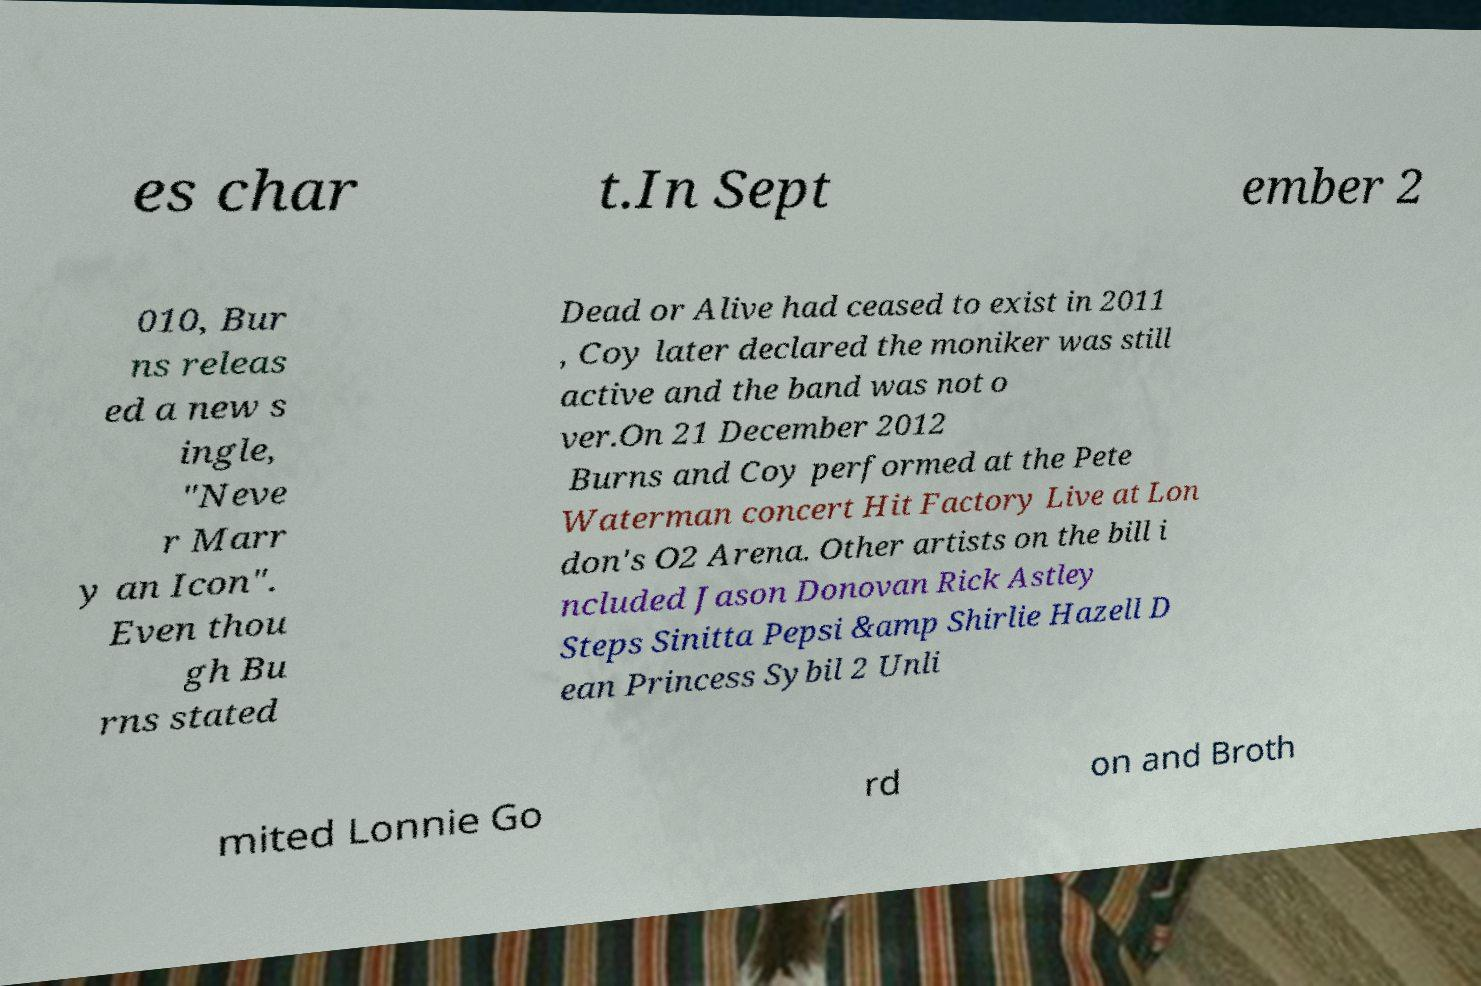I need the written content from this picture converted into text. Can you do that? es char t.In Sept ember 2 010, Bur ns releas ed a new s ingle, "Neve r Marr y an Icon". Even thou gh Bu rns stated Dead or Alive had ceased to exist in 2011 , Coy later declared the moniker was still active and the band was not o ver.On 21 December 2012 Burns and Coy performed at the Pete Waterman concert Hit Factory Live at Lon don's O2 Arena. Other artists on the bill i ncluded Jason Donovan Rick Astley Steps Sinitta Pepsi &amp Shirlie Hazell D ean Princess Sybil 2 Unli mited Lonnie Go rd on and Broth 